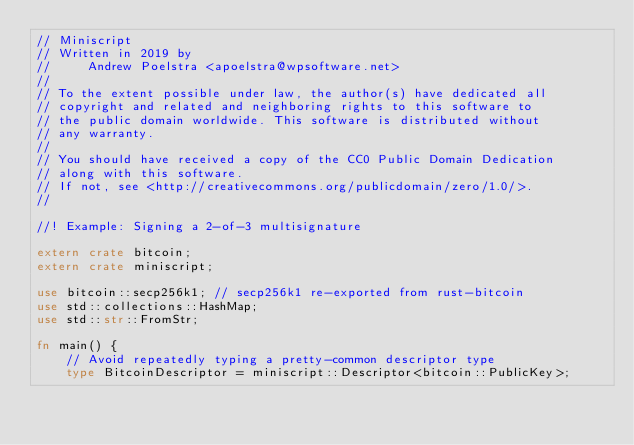<code> <loc_0><loc_0><loc_500><loc_500><_Rust_>// Miniscript
// Written in 2019 by
//     Andrew Poelstra <apoelstra@wpsoftware.net>
//
// To the extent possible under law, the author(s) have dedicated all
// copyright and related and neighboring rights to this software to
// the public domain worldwide. This software is distributed without
// any warranty.
//
// You should have received a copy of the CC0 Public Domain Dedication
// along with this software.
// If not, see <http://creativecommons.org/publicdomain/zero/1.0/>.
//

//! Example: Signing a 2-of-3 multisignature

extern crate bitcoin;
extern crate miniscript;

use bitcoin::secp256k1; // secp256k1 re-exported from rust-bitcoin
use std::collections::HashMap;
use std::str::FromStr;

fn main() {
    // Avoid repeatedly typing a pretty-common descriptor type
    type BitcoinDescriptor = miniscript::Descriptor<bitcoin::PublicKey>;
</code> 